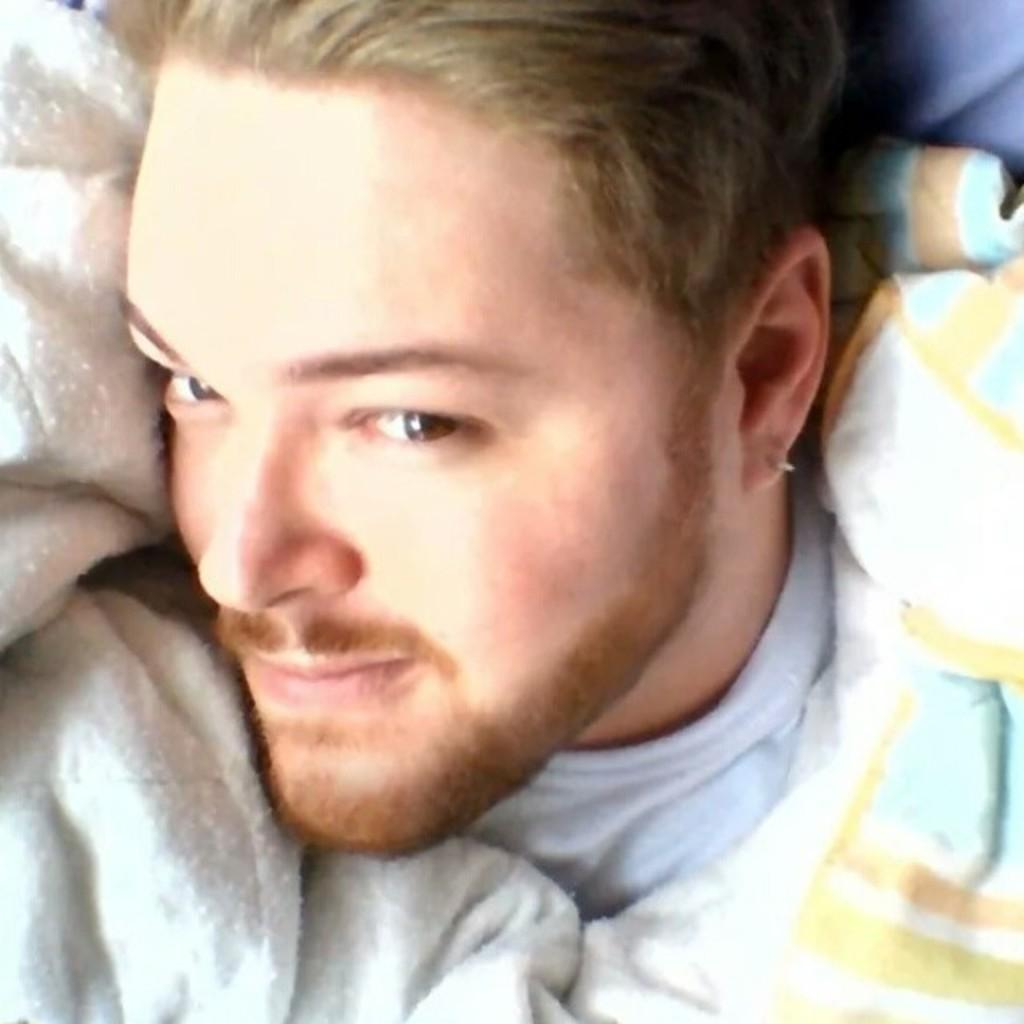What is the main subject of the image? There is a person in the image. Can you describe the person's attire? The person is wearing clothes. How many bottles are visible in the image? There are no bottles present in the image. What type of story is being told by the person in the image? There is no story being told in the image; it only shows a person wearing clothes. 